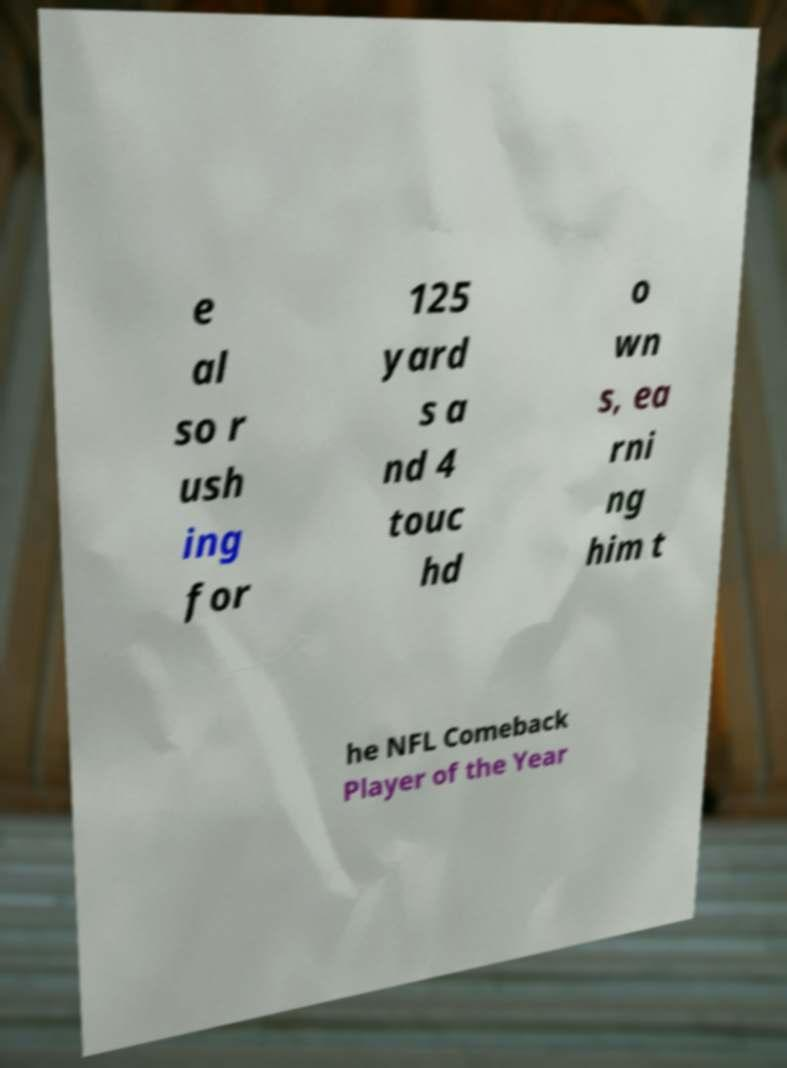Could you assist in decoding the text presented in this image and type it out clearly? e al so r ush ing for 125 yard s a nd 4 touc hd o wn s, ea rni ng him t he NFL Comeback Player of the Year 